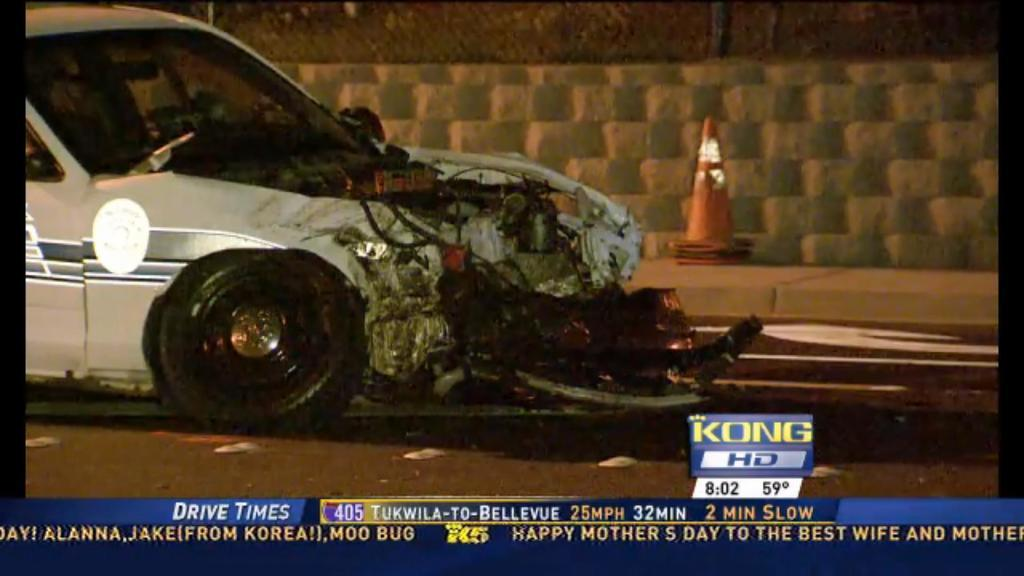<image>
Share a concise interpretation of the image provided. a Kong news broadcast of an accident with a car 